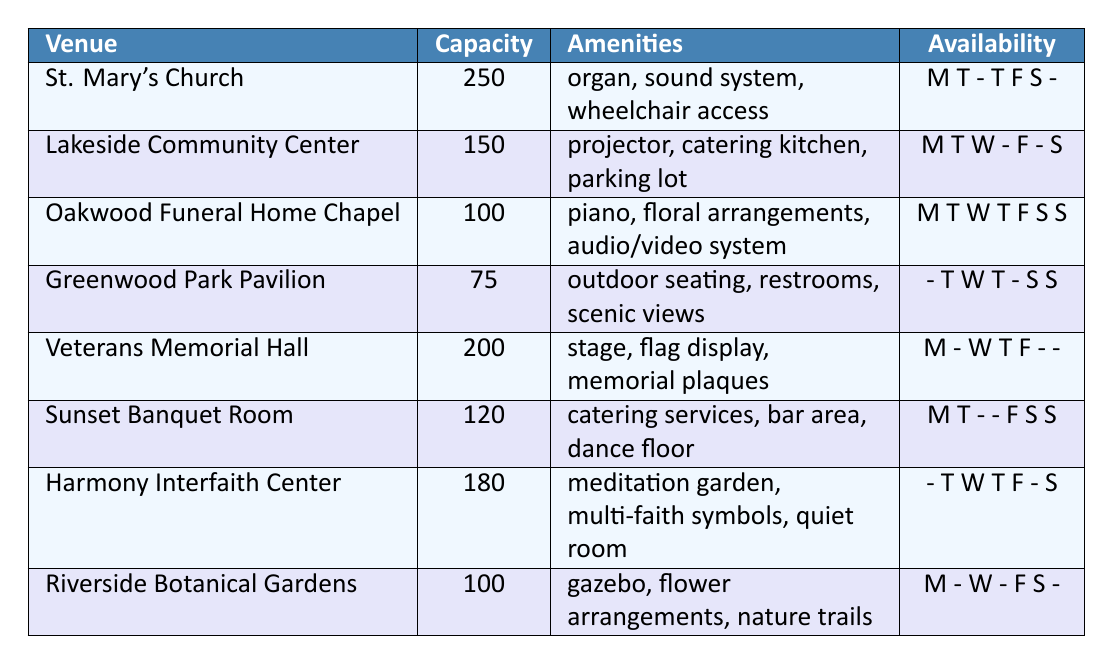What is the capacity of Lakeside Community Center? The table lists Lakeside Community Center with a capacity of 150.
Answer: 150 Which venue offers wheelchair access? The venue St. Mary's Church has "wheelchair access" listed in the amenities.
Answer: St. Mary's Church How many venues have a capacity of 100 or more? By counting the venues with a capacity of 100 or greater, we find Oakwood Funeral Home Chapel, Lakeside Community Center, Veterans Memorial Hall, and St. Mary's Church. This is 4 venues in total.
Answer: 4 Is Sunset Banquet Room available on Friday? Looking at the availability for Sunset Banquet Room, we see 'F' (Friday) is marked; thus, it is available on that day.
Answer: Yes How many venues have an outdoor seating option? The only venue that lists "outdoor seating" as an amenity is Greenwood Park Pavilion.
Answer: 1 Which venue has the most amenities? By comparing the amenities listed for each venue, Lakeside Community Center has three amenities: projector, catering kitchen, and parking lot, matching the highest count along with Sunset Banquet Room and Oakwood Funeral Home Chapel.
Answer: Lakeside Community Center / Oakwood Funeral Home Chapel / Sunset Banquet Room Is there any venue where the availability is consistent throughout the week? Oakwood Funeral Home Chapel is available every day of the week, as indicated by 'M T W T F S S'.
Answer: Yes Which venue has the highest capacity? The table shows St. Mary's Church has the highest capacity listed at 250.
Answer: St. Mary's Church Identify the days when Greenwood Park Pavilion is available? The availability for Greenwood Park Pavilion shows it is available on Tuesday, Wednesday, Thursday, Saturday, and Sunday, as indicated by 'T W T S S'.
Answer: Tuesday, Wednesday, Thursday, Saturday, Sunday Are there any venues that do not have a projector? A quick check shows that St. Mary's Church, Oakwood Funeral Home Chapel, Veteran’s Memorial Hall, Harmony Interfaith Center, and Riverside Botanical Gardens do not list a projector as an amenity.
Answer: Yes 